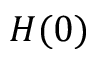Convert formula to latex. <formula><loc_0><loc_0><loc_500><loc_500>H ( 0 )</formula> 